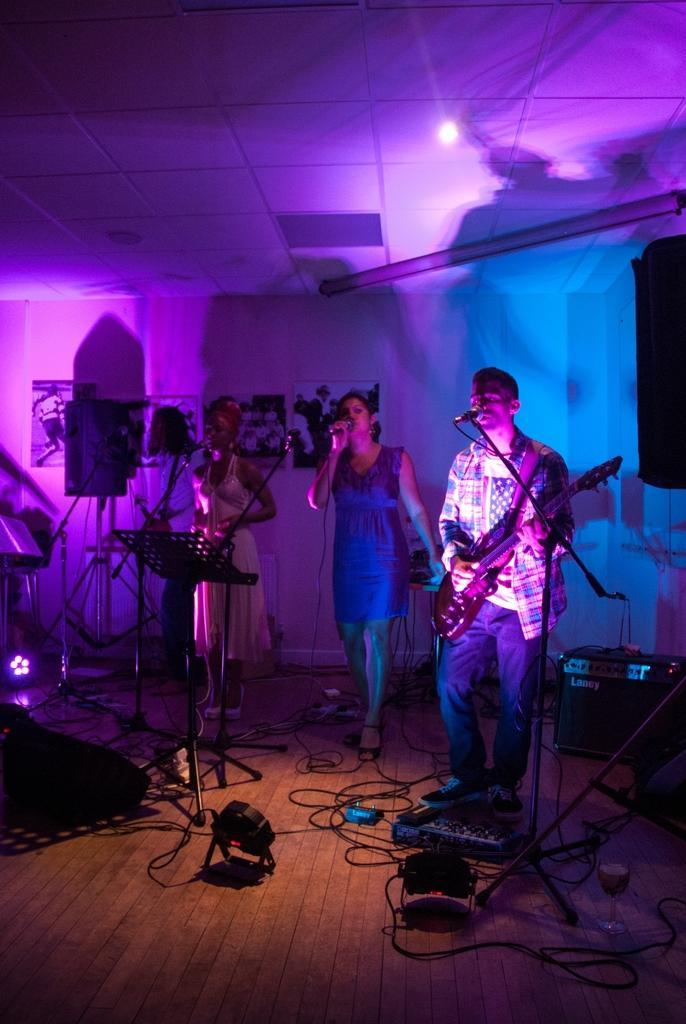Can you describe this image briefly? It is party there are three people standing on the floor and singing the song and two of them are playing music also and around the people there are some other instruments,there is a pink light flashing around the room. 